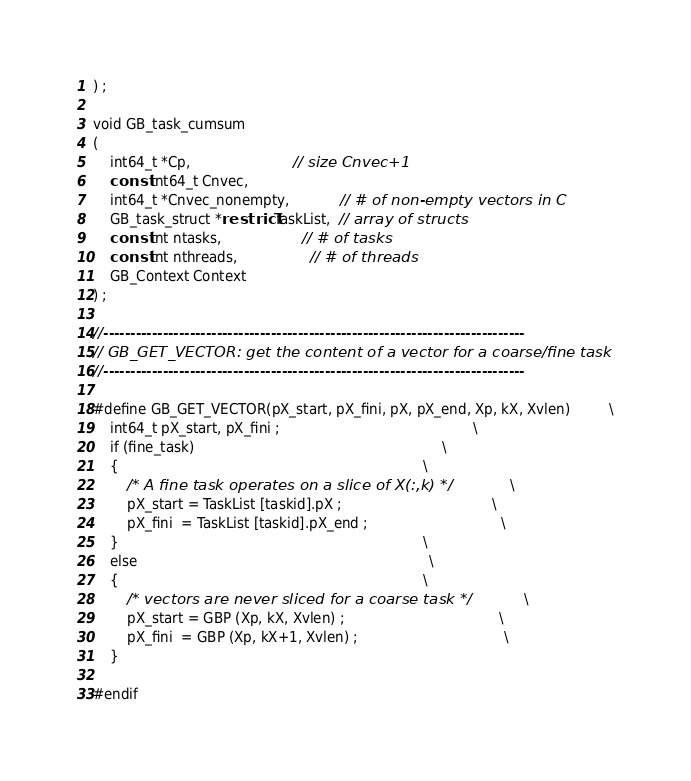<code> <loc_0><loc_0><loc_500><loc_500><_C_>) ;

void GB_task_cumsum
(
    int64_t *Cp,                        // size Cnvec+1
    const int64_t Cnvec,
    int64_t *Cnvec_nonempty,            // # of non-empty vectors in C
    GB_task_struct *restrict TaskList,  // array of structs
    const int ntasks,                   // # of tasks
    const int nthreads,                 // # of threads
    GB_Context Context
) ;

//------------------------------------------------------------------------------
// GB_GET_VECTOR: get the content of a vector for a coarse/fine task
//------------------------------------------------------------------------------

#define GB_GET_VECTOR(pX_start, pX_fini, pX, pX_end, Xp, kX, Xvlen)         \
    int64_t pX_start, pX_fini ;                                             \
    if (fine_task)                                                          \
    {                                                                       \
        /* A fine task operates on a slice of X(:,k) */                     \
        pX_start = TaskList [taskid].pX ;                                   \
        pX_fini  = TaskList [taskid].pX_end ;                               \
    }                                                                       \
    else                                                                    \
    {                                                                       \
        /* vectors are never sliced for a coarse task */                    \
        pX_start = GBP (Xp, kX, Xvlen) ;                                    \
        pX_fini  = GBP (Xp, kX+1, Xvlen) ;                                  \
    }

#endif

</code> 